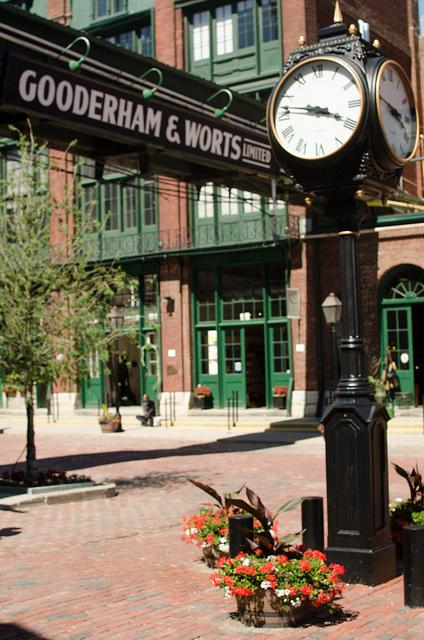In which setting is this clock? Please explain your reasoning. urban. The clock is in a setting with tall buildings all around. 